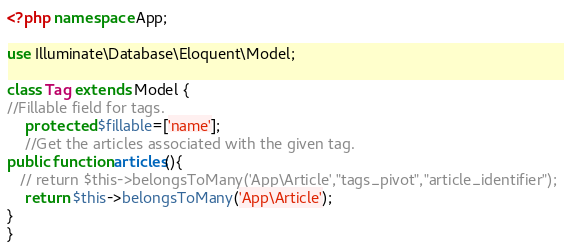Convert code to text. <code><loc_0><loc_0><loc_500><loc_500><_PHP_><?php namespace App;

use Illuminate\Database\Eloquent\Model;

class Tag extends Model {
//Fillable field for tags.
    protected $fillable=['name'];
	//Get the articles associated with the given tag.
public function articles(){
   // return $this->belongsToMany('App\Article',"tags_pivot","article_identifier");
    return $this->belongsToMany('App\Article');
}
}
</code> 